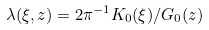Convert formula to latex. <formula><loc_0><loc_0><loc_500><loc_500>\lambda ( \xi , z ) = 2 \pi ^ { - 1 } K _ { 0 } ( \xi ) / G _ { 0 } ( z )</formula> 